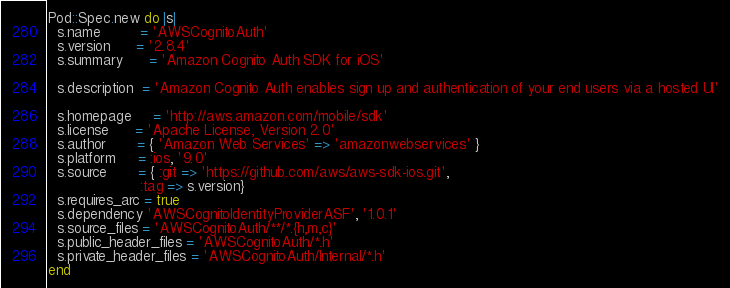<code> <loc_0><loc_0><loc_500><loc_500><_Ruby_>Pod::Spec.new do |s|
  s.name         = 'AWSCognitoAuth'
  s.version      = '2.8.4'
  s.summary      = 'Amazon Cognito Auth SDK for iOS'

  s.description  = 'Amazon Cognito Auth enables sign up and authentication of your end users via a hosted UI'

  s.homepage     = 'http://aws.amazon.com/mobile/sdk'
  s.license      = 'Apache License, Version 2.0'
  s.author       = { 'Amazon Web Services' => 'amazonwebservices' }
  s.platform     = :ios, '9.0'
  s.source       = { :git => 'https://github.com/aws/aws-sdk-ios.git',
                     :tag => s.version}
  s.requires_arc = true
  s.dependency 'AWSCognitoIdentityProviderASF', '1.0.1'
  s.source_files = 'AWSCognitoAuth/**/*.{h,m,c}'
  s.public_header_files = 'AWSCognitoAuth/*.h'
  s.private_header_files = 'AWSCognitoAuth/Internal/*.h'
end
</code> 